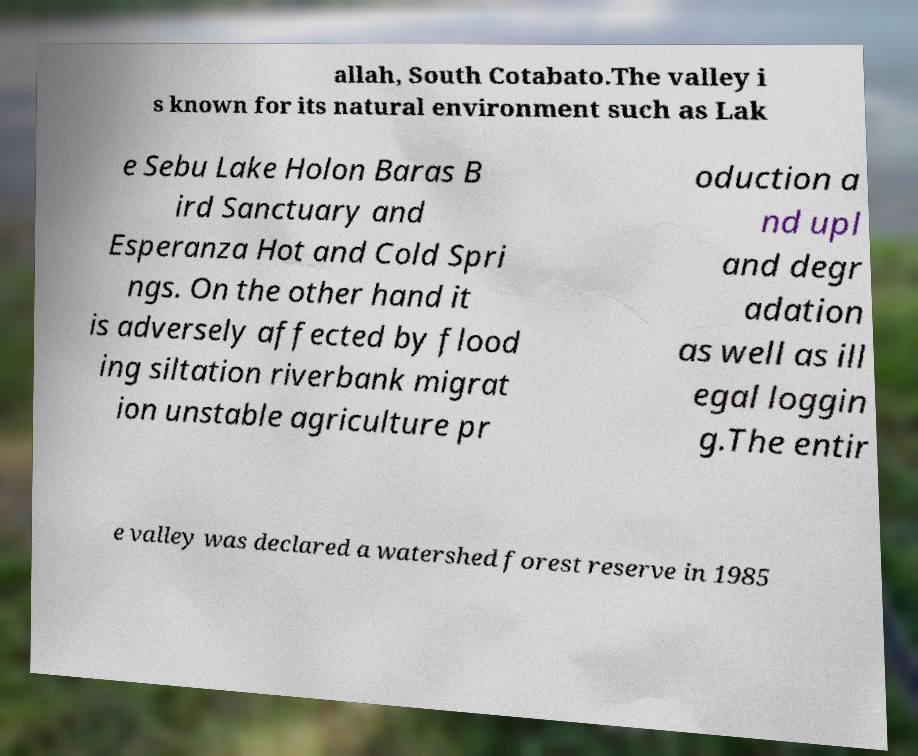Could you extract and type out the text from this image? allah, South Cotabato.The valley i s known for its natural environment such as Lak e Sebu Lake Holon Baras B ird Sanctuary and Esperanza Hot and Cold Spri ngs. On the other hand it is adversely affected by flood ing siltation riverbank migrat ion unstable agriculture pr oduction a nd upl and degr adation as well as ill egal loggin g.The entir e valley was declared a watershed forest reserve in 1985 